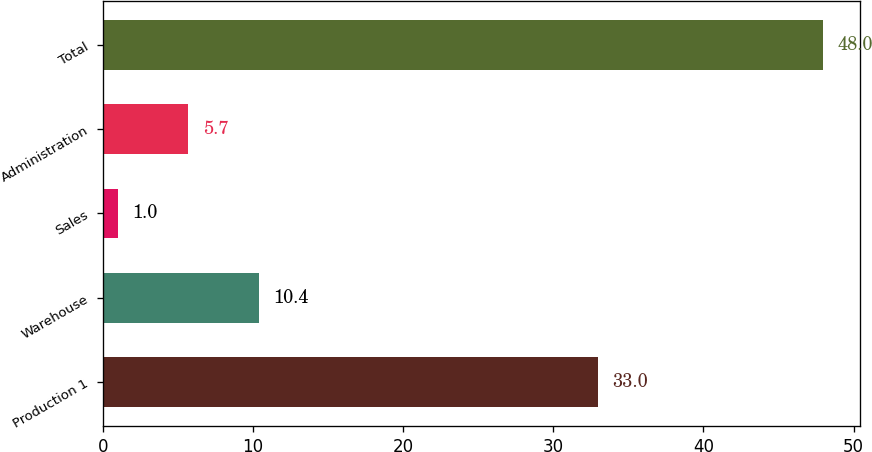Convert chart to OTSL. <chart><loc_0><loc_0><loc_500><loc_500><bar_chart><fcel>Production 1<fcel>Warehouse<fcel>Sales<fcel>Administration<fcel>Total<nl><fcel>33<fcel>10.4<fcel>1<fcel>5.7<fcel>48<nl></chart> 